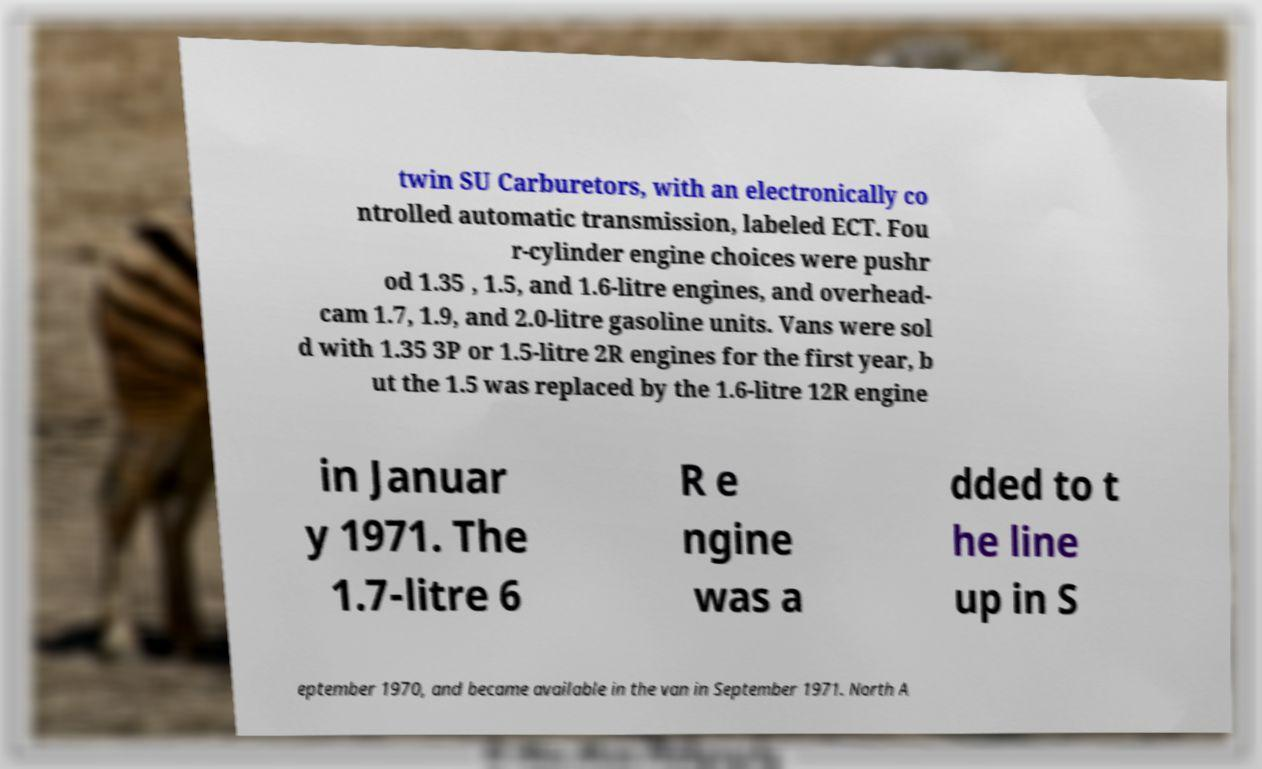Please identify and transcribe the text found in this image. twin SU Carburetors, with an electronically co ntrolled automatic transmission, labeled ECT. Fou r-cylinder engine choices were pushr od 1.35 , 1.5, and 1.6-litre engines, and overhead- cam 1.7, 1.9, and 2.0-litre gasoline units. Vans were sol d with 1.35 3P or 1.5-litre 2R engines for the first year, b ut the 1.5 was replaced by the 1.6-litre 12R engine in Januar y 1971. The 1.7-litre 6 R e ngine was a dded to t he line up in S eptember 1970, and became available in the van in September 1971. North A 